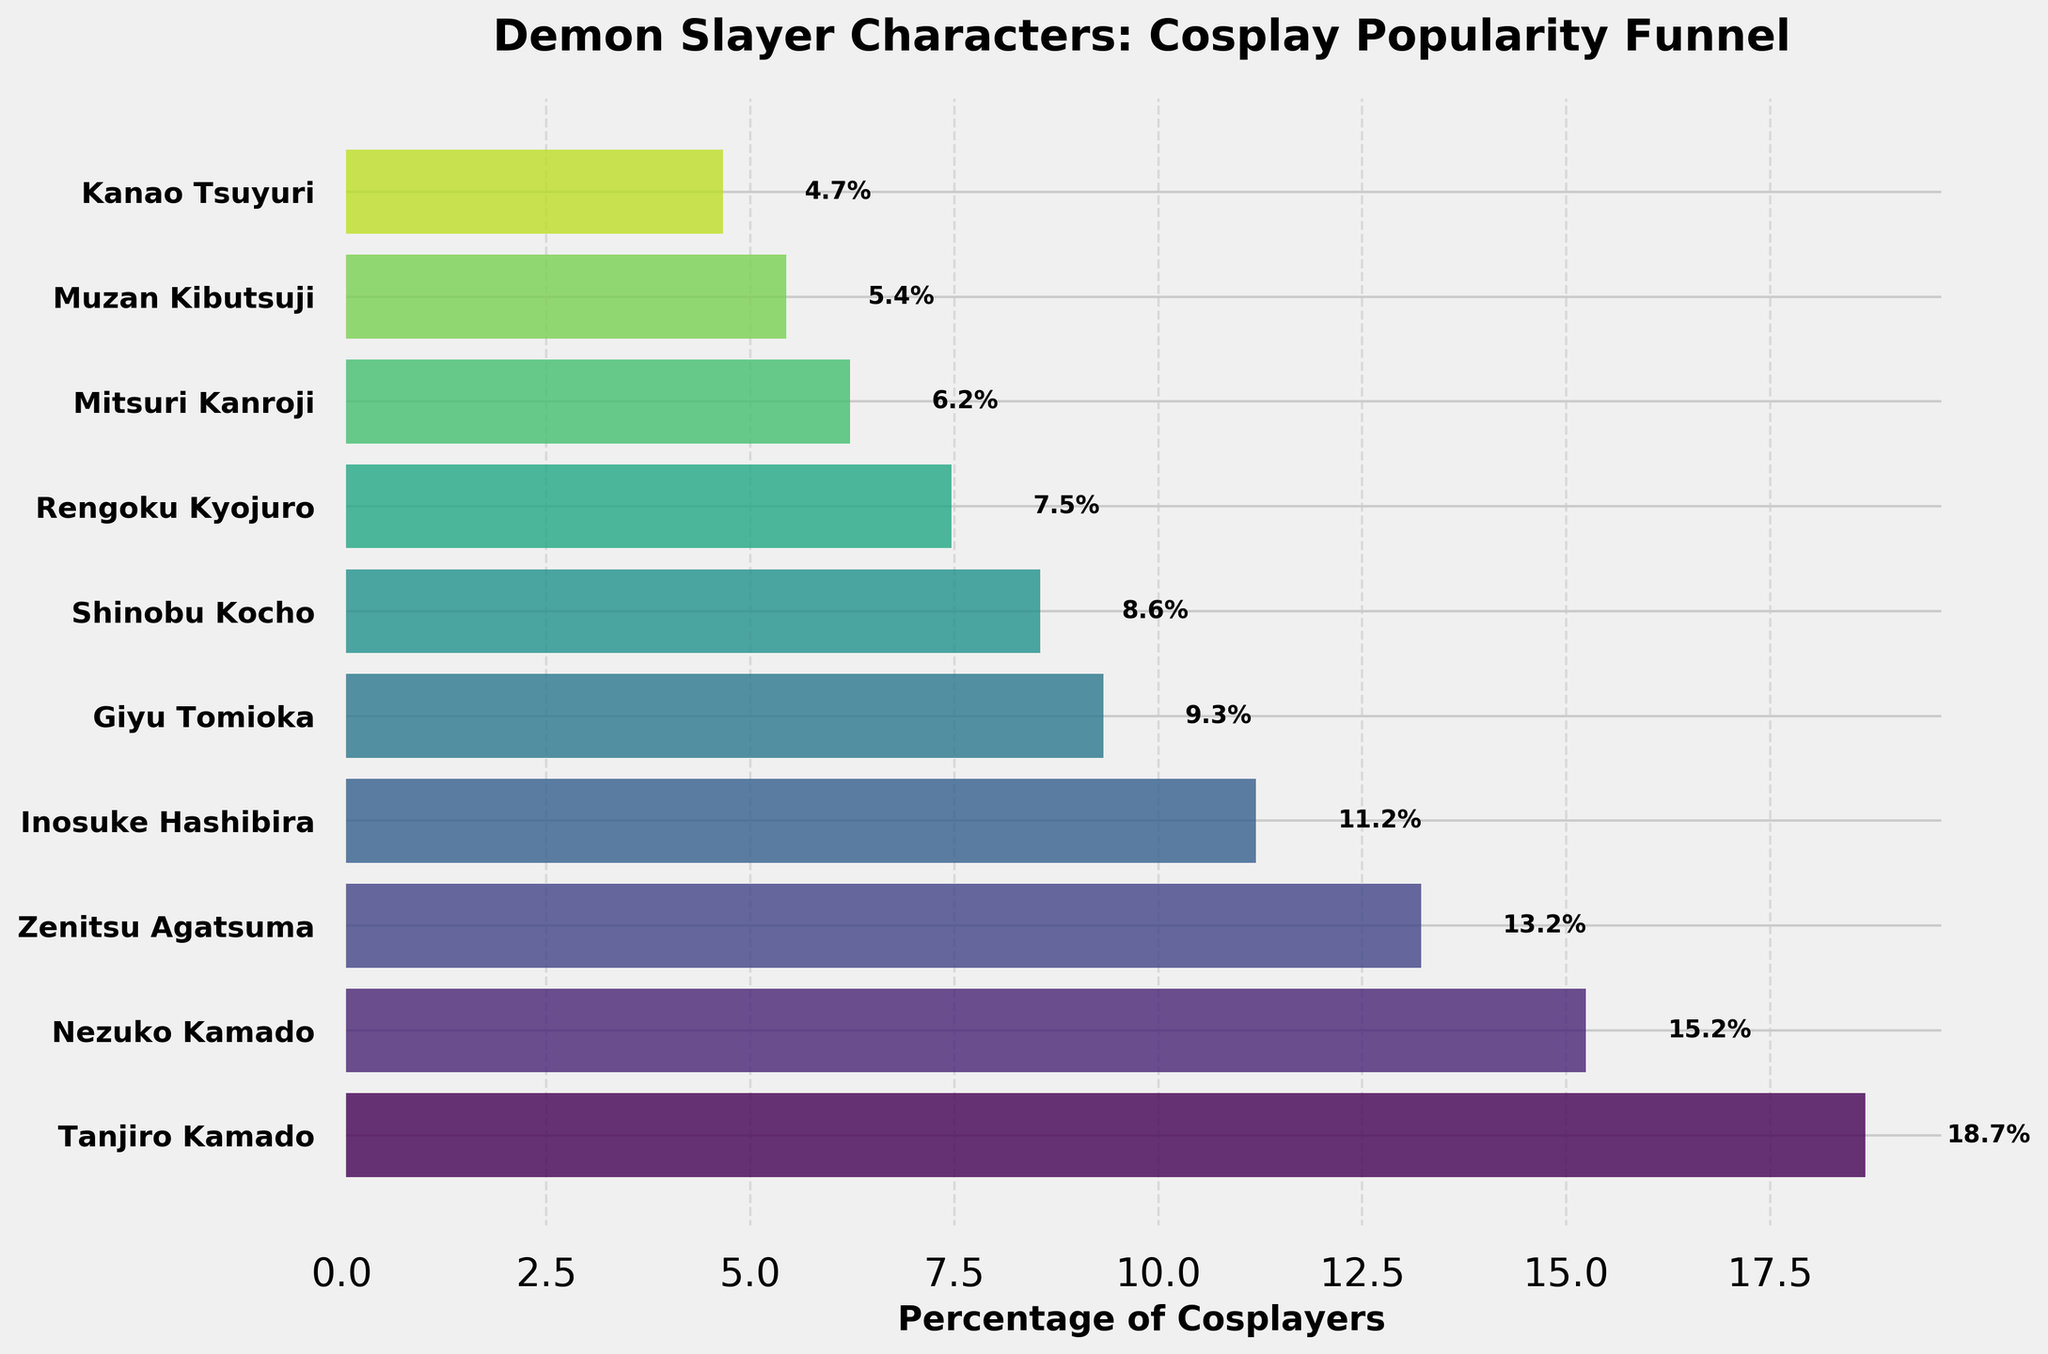What is the title of the plot? The title is usually found at the top of the plot. In this case, the title is given as "Demon Slayer Characters: Cosplay Popularity Funnel".
Answer: Demon Slayer Characters: Cosplay Popularity Funnel How many characters are included in the funnel chart? Each horizontal bar in the funnel chart represents a different character. By counting these bars, we can see that there are 10 characters included.
Answer: 10 Which character has the highest cosplay frequency? The character with the widest bar at the top of the funnel chart indicates the highest cosplay frequency. This character is "Tanjiro Kamado".
Answer: Tanjiro Kamado Between Nezuko Kamado and Zenitsu Agatsuma, who is more frequently cosplayed and by what margin? Nezuko Kamado has a higher frequency compared to Zenitsu Agatsuma. Nezuko Kamado's bar is the second widest, and Zenitsu's the third. By looking at the percentages next to their bars, we see Nezuko at approximately 19.7% and Zenitsu at around 17.1%, making the margin 19.7% - 17.1% = 2.6%.
Answer: Nezuko Kamado by 2.6% Who is the least cosplayed character in the funnel chart? The least cosplayed character will have the narrowest bar at the very bottom of the funnel chart. In this chart, it is "Kanao Tsuyuri".
Answer: Kanao Tsuyuri What is the combined cosplay frequency percentage of Giyu Tomioka and Shinobu Kocho? Giyu Tomioka has a frequency percentage of around 9.9% and Shinobu Kocho around 9.1%. Adding these percentages together gives 9.9% + 9.1% = 19%.
Answer: 19% What percentage of cosplayers choose characters other than Tanjiro Kamado? Tanjiro Kamado has a percentage of around 24.6%. Therefore, the percentage of cosplayers choosing other characters is 100% - 24.6% = 75.4%.
Answer: 75.4% How does Rengoku Kyojuro's cosplay popularity compare to Mitsuri Kanroji's in terms of percentage? Rengoku Kyojuro has a percentage of approximately 8.2%, while Mitsuri Kanroji has around 6.8%. Comparing these shows that Rengoku Kyojuro has a higher percentage by about 1.4%.
Answer: Rengoku Kyojuro is 1.4% more popular What’s the combined percentage of the top three cosplayed characters? The top three characters are Tanjiro Kamado (24.6%), Nezuko Kamado (19.7%), and Zenitsu Agatsuma (17.1%). Summing these gives 24.6% + 19.7% + 17.1% = 61.4%.
Answer: 61.4% By how much does Inosuke Hashibira's cosplay frequency exceed that of Muzan Kibutsuji? Inosuke Hashibira has a percentage of about 14.8%, and Muzan Kibutsuji has around 7.2%. The difference is 14.8% - 7.2% = 7.6%.
Answer: 7.6% 